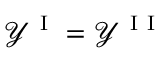<formula> <loc_0><loc_0><loc_500><loc_500>\mathcal { Y } ^ { I } = \mathcal { Y } ^ { I I }</formula> 